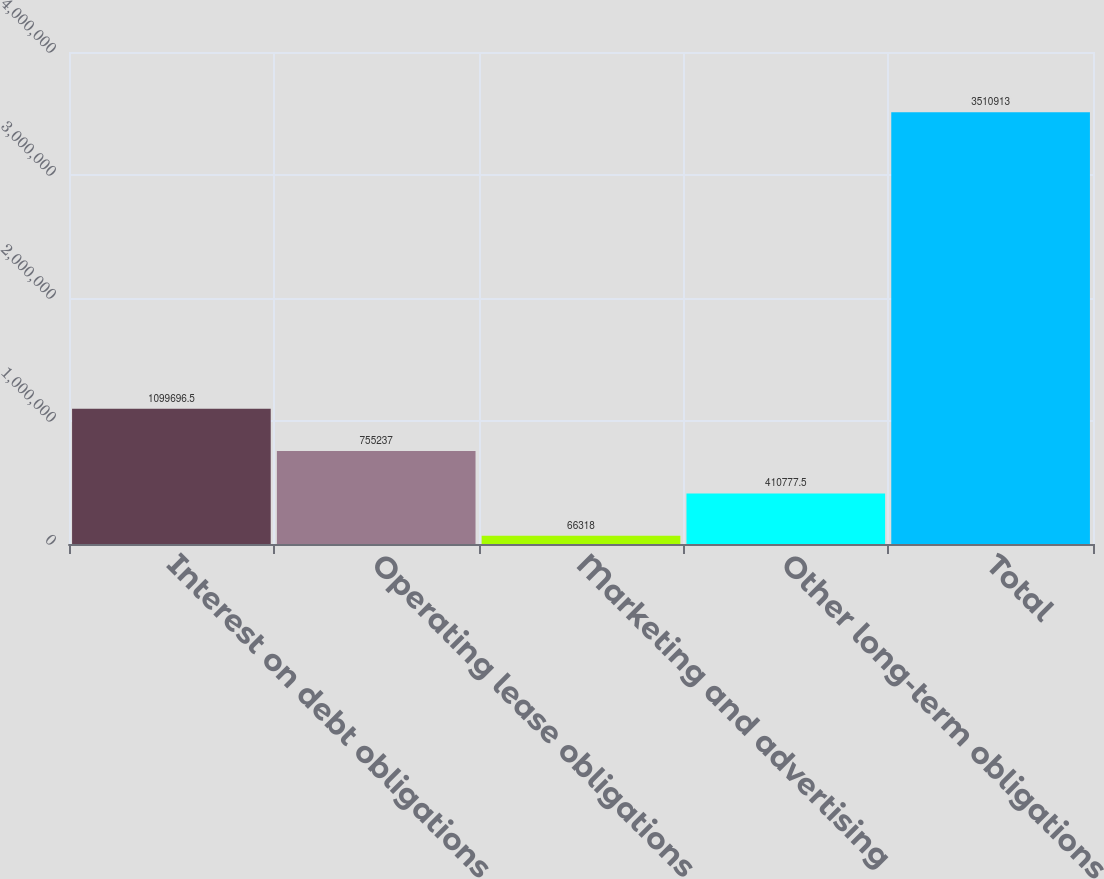<chart> <loc_0><loc_0><loc_500><loc_500><bar_chart><fcel>Interest on debt obligations<fcel>Operating lease obligations<fcel>Marketing and advertising<fcel>Other long-term obligations<fcel>Total<nl><fcel>1.0997e+06<fcel>755237<fcel>66318<fcel>410778<fcel>3.51091e+06<nl></chart> 